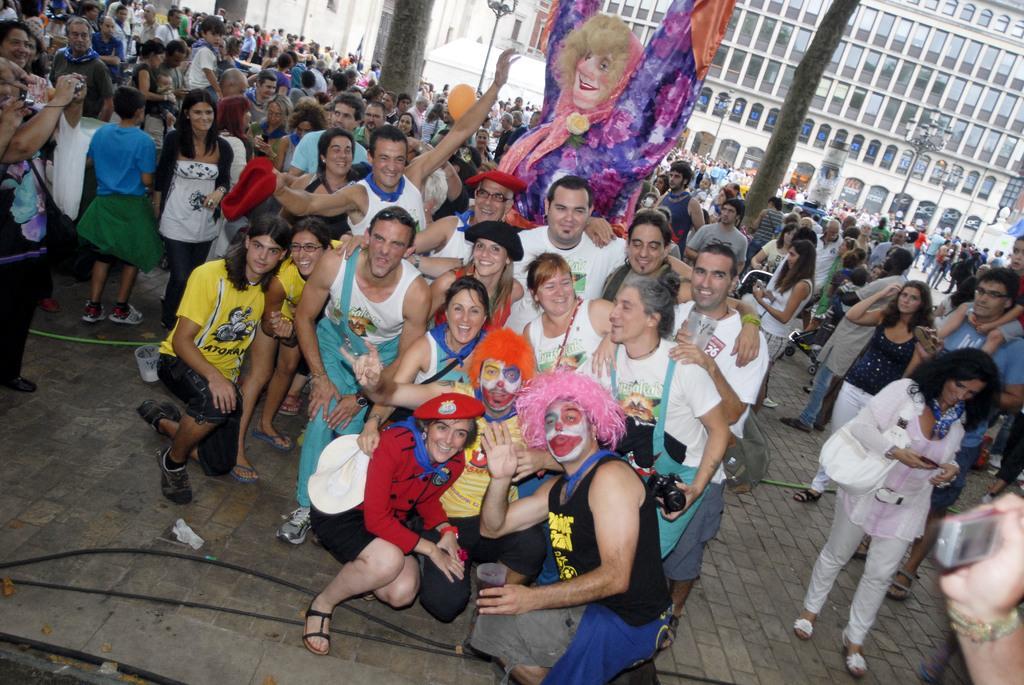Could you give a brief overview of what you see in this image? In this image, we can see a group of people are on the floor. Few are smiling and holding some objects. Here we can see the wires. Background there are so many buildings, poles, pillars, glass windows. 